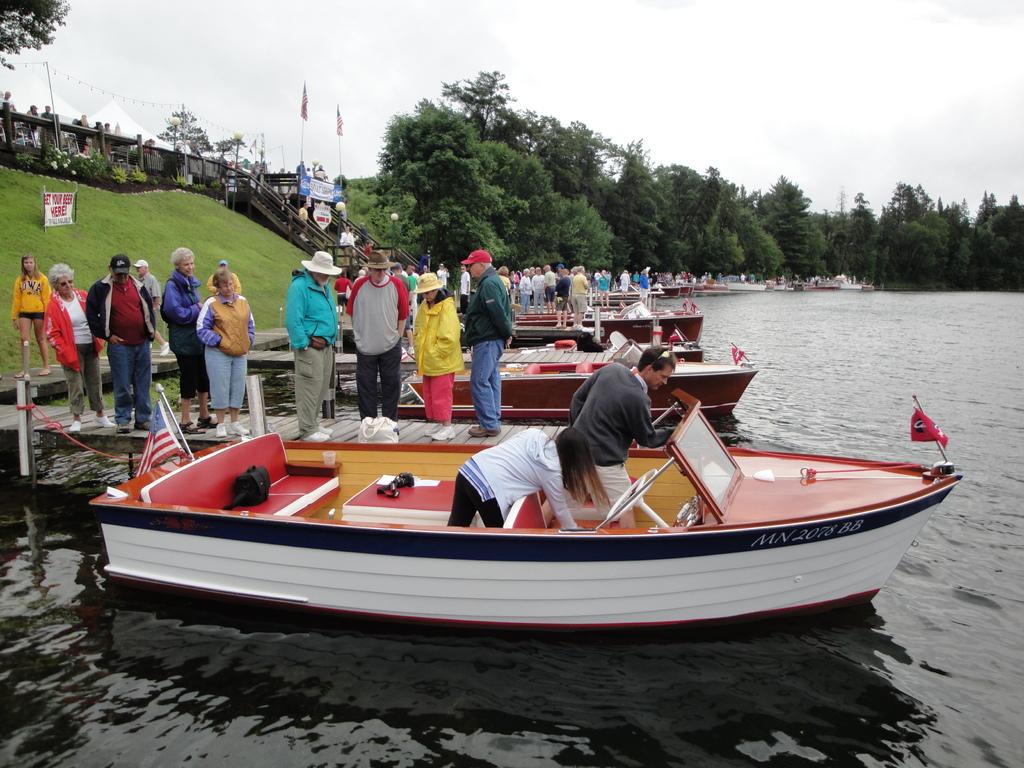What is written on the side of the boat?
Your response must be concise. Unanswerable. 